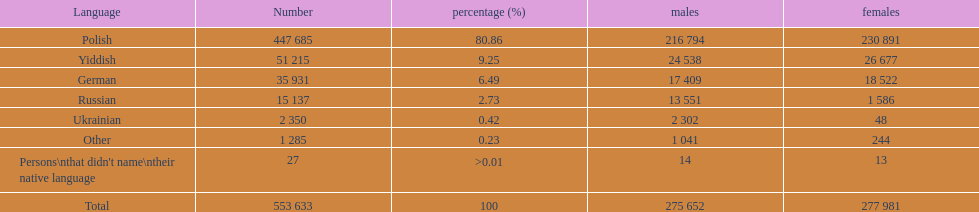Which language did only .42% of people in the imperial census of 1897 speak in the p&#322;ock governorate? Ukrainian. 